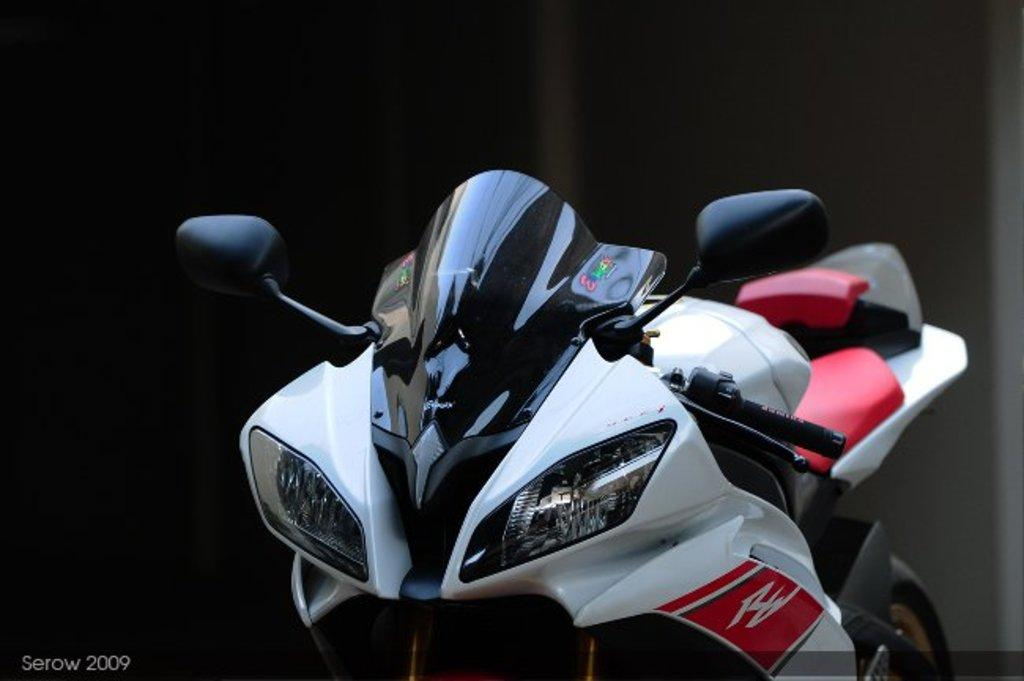What is the main object in the image? There is a bike in the image. Can you describe the background of the image? The background of the image is dark. What additional information can be found in the bottom left side of the image? There is text and a number in the bottom left side of the image. How many ants are crawling on the bike in the image? There are no ants present in the image; it only features a bike and some text and a number in the bottom left side. 